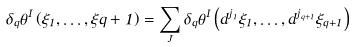Convert formula to latex. <formula><loc_0><loc_0><loc_500><loc_500>\delta _ { q } \theta ^ { I } \left ( \xi _ { 1 } , \dots , \xi q + 1 \right ) = \sum _ { J } \delta _ { q } \theta ^ { I } \left ( d ^ { j _ { 1 } } \xi _ { 1 } , \dots , d ^ { j _ { q + 1 } } \xi _ { q + 1 } \right )</formula> 